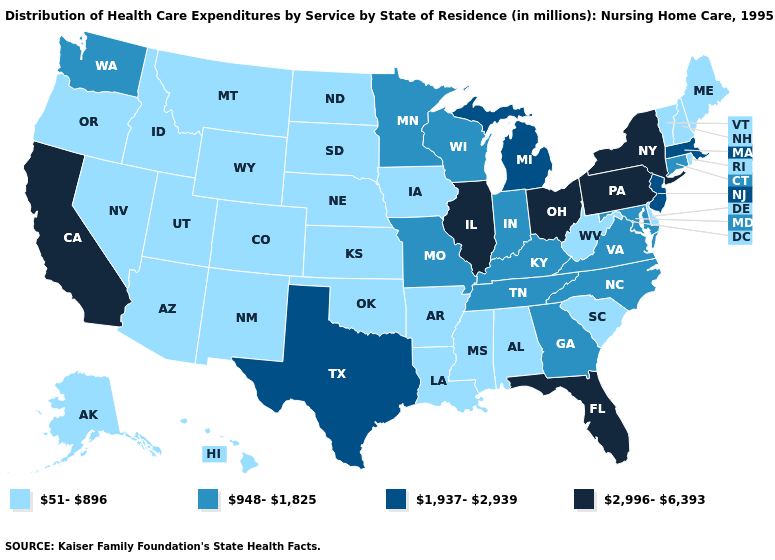What is the lowest value in the USA?
Keep it brief. 51-896. Name the states that have a value in the range 51-896?
Give a very brief answer. Alabama, Alaska, Arizona, Arkansas, Colorado, Delaware, Hawaii, Idaho, Iowa, Kansas, Louisiana, Maine, Mississippi, Montana, Nebraska, Nevada, New Hampshire, New Mexico, North Dakota, Oklahoma, Oregon, Rhode Island, South Carolina, South Dakota, Utah, Vermont, West Virginia, Wyoming. Does Connecticut have the same value as Washington?
Keep it brief. Yes. Is the legend a continuous bar?
Give a very brief answer. No. What is the value of Kentucky?
Concise answer only. 948-1,825. What is the highest value in states that border North Carolina?
Be succinct. 948-1,825. What is the lowest value in the Northeast?
Short answer required. 51-896. Name the states that have a value in the range 948-1,825?
Give a very brief answer. Connecticut, Georgia, Indiana, Kentucky, Maryland, Minnesota, Missouri, North Carolina, Tennessee, Virginia, Washington, Wisconsin. Does Maine have the lowest value in the Northeast?
Quick response, please. Yes. Does Utah have a higher value than Georgia?
Answer briefly. No. Does Indiana have a higher value than Louisiana?
Answer briefly. Yes. Does the map have missing data?
Write a very short answer. No. What is the value of West Virginia?
Answer briefly. 51-896. Which states hav the highest value in the West?
Be succinct. California. Does Arizona have a higher value than Massachusetts?
Short answer required. No. 